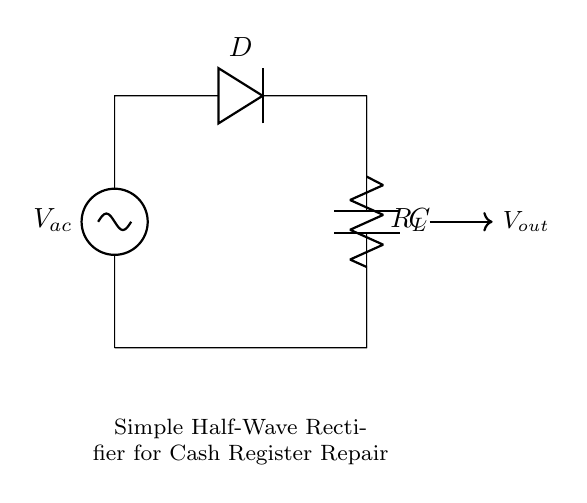What is the input type of this circuit? The input is AC, indicated by the AC voltage source symbol at the top of the circuit diagram.
Answer: AC What does the diode do in this circuit? The diode allows current to flow in one direction, effectively blocking the reverse current during the negative half-cycle, thus creating a pulsed output voltage.
Answer: Rectifies What is the function of the resistor labeled R_L? The resistor R_L acts as a load component in the circuit, consuming the electrical power coming from the rectifier output.
Answer: Load What is the role of the capacitor C in this circuit? The capacitor C smooths the output voltage by storing and releasing charge, reducing the ripple voltage in the rectified output.
Answer: Smoothing What type of rectifier is represented here? The circuit is a half-wave rectifier as it only utilizes one half of the AC input cycle for output, allowing current flow during the positive half-cycle only.
Answer: Half-wave 